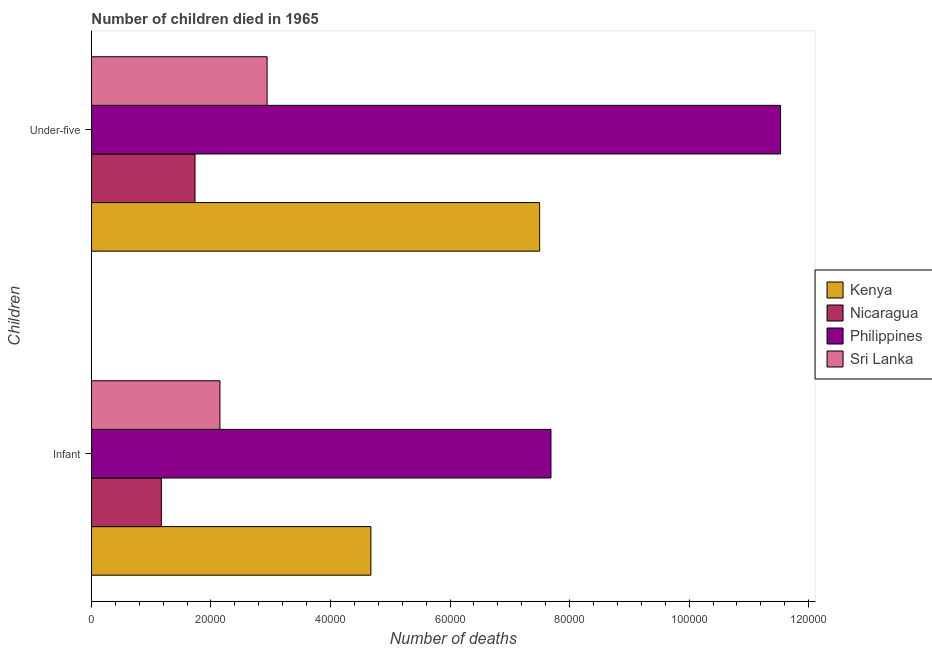How many different coloured bars are there?
Make the answer very short. 4. How many bars are there on the 2nd tick from the top?
Ensure brevity in your answer.  4. What is the label of the 2nd group of bars from the top?
Your response must be concise. Infant. What is the number of under-five deaths in Sri Lanka?
Provide a succinct answer. 2.94e+04. Across all countries, what is the maximum number of infant deaths?
Ensure brevity in your answer.  7.69e+04. Across all countries, what is the minimum number of under-five deaths?
Your response must be concise. 1.73e+04. In which country was the number of under-five deaths minimum?
Your answer should be compact. Nicaragua. What is the total number of under-five deaths in the graph?
Your answer should be compact. 2.37e+05. What is the difference between the number of infant deaths in Sri Lanka and that in Kenya?
Offer a terse response. -2.53e+04. What is the difference between the number of under-five deaths in Philippines and the number of infant deaths in Sri Lanka?
Your response must be concise. 9.38e+04. What is the average number of infant deaths per country?
Your answer should be compact. 3.92e+04. What is the difference between the number of infant deaths and number of under-five deaths in Sri Lanka?
Give a very brief answer. -7895. In how many countries, is the number of under-five deaths greater than 36000 ?
Your answer should be compact. 2. What is the ratio of the number of infant deaths in Nicaragua to that in Kenya?
Give a very brief answer. 0.25. Is the number of infant deaths in Kenya less than that in Nicaragua?
Give a very brief answer. No. In how many countries, is the number of infant deaths greater than the average number of infant deaths taken over all countries?
Make the answer very short. 2. What does the 4th bar from the top in Infant represents?
Offer a very short reply. Kenya. What does the 4th bar from the bottom in Under-five represents?
Ensure brevity in your answer.  Sri Lanka. How many bars are there?
Make the answer very short. 8. Are all the bars in the graph horizontal?
Offer a very short reply. Yes. How many countries are there in the graph?
Give a very brief answer. 4. Are the values on the major ticks of X-axis written in scientific E-notation?
Make the answer very short. No. Does the graph contain any zero values?
Provide a succinct answer. No. Where does the legend appear in the graph?
Make the answer very short. Center right. How many legend labels are there?
Offer a terse response. 4. What is the title of the graph?
Your response must be concise. Number of children died in 1965. Does "Solomon Islands" appear as one of the legend labels in the graph?
Your response must be concise. No. What is the label or title of the X-axis?
Your answer should be very brief. Number of deaths. What is the label or title of the Y-axis?
Your answer should be compact. Children. What is the Number of deaths of Kenya in Infant?
Provide a short and direct response. 4.68e+04. What is the Number of deaths in Nicaragua in Infant?
Offer a very short reply. 1.17e+04. What is the Number of deaths in Philippines in Infant?
Keep it short and to the point. 7.69e+04. What is the Number of deaths of Sri Lanka in Infant?
Your answer should be compact. 2.15e+04. What is the Number of deaths of Kenya in Under-five?
Give a very brief answer. 7.50e+04. What is the Number of deaths in Nicaragua in Under-five?
Your answer should be compact. 1.73e+04. What is the Number of deaths in Philippines in Under-five?
Your response must be concise. 1.15e+05. What is the Number of deaths of Sri Lanka in Under-five?
Ensure brevity in your answer.  2.94e+04. Across all Children, what is the maximum Number of deaths of Kenya?
Give a very brief answer. 7.50e+04. Across all Children, what is the maximum Number of deaths of Nicaragua?
Provide a succinct answer. 1.73e+04. Across all Children, what is the maximum Number of deaths in Philippines?
Your answer should be compact. 1.15e+05. Across all Children, what is the maximum Number of deaths in Sri Lanka?
Provide a succinct answer. 2.94e+04. Across all Children, what is the minimum Number of deaths of Kenya?
Your response must be concise. 4.68e+04. Across all Children, what is the minimum Number of deaths of Nicaragua?
Provide a short and direct response. 1.17e+04. Across all Children, what is the minimum Number of deaths in Philippines?
Ensure brevity in your answer.  7.69e+04. Across all Children, what is the minimum Number of deaths of Sri Lanka?
Offer a very short reply. 2.15e+04. What is the total Number of deaths in Kenya in the graph?
Provide a short and direct response. 1.22e+05. What is the total Number of deaths in Nicaragua in the graph?
Offer a terse response. 2.90e+04. What is the total Number of deaths in Philippines in the graph?
Provide a short and direct response. 1.92e+05. What is the total Number of deaths in Sri Lanka in the graph?
Give a very brief answer. 5.09e+04. What is the difference between the Number of deaths of Kenya in Infant and that in Under-five?
Make the answer very short. -2.82e+04. What is the difference between the Number of deaths of Nicaragua in Infant and that in Under-five?
Give a very brief answer. -5639. What is the difference between the Number of deaths in Philippines in Infant and that in Under-five?
Provide a succinct answer. -3.84e+04. What is the difference between the Number of deaths of Sri Lanka in Infant and that in Under-five?
Offer a terse response. -7895. What is the difference between the Number of deaths in Kenya in Infant and the Number of deaths in Nicaragua in Under-five?
Ensure brevity in your answer.  2.94e+04. What is the difference between the Number of deaths of Kenya in Infant and the Number of deaths of Philippines in Under-five?
Offer a terse response. -6.85e+04. What is the difference between the Number of deaths in Kenya in Infant and the Number of deaths in Sri Lanka in Under-five?
Make the answer very short. 1.74e+04. What is the difference between the Number of deaths in Nicaragua in Infant and the Number of deaths in Philippines in Under-five?
Your answer should be very brief. -1.04e+05. What is the difference between the Number of deaths in Nicaragua in Infant and the Number of deaths in Sri Lanka in Under-five?
Your answer should be very brief. -1.77e+04. What is the difference between the Number of deaths of Philippines in Infant and the Number of deaths of Sri Lanka in Under-five?
Offer a very short reply. 4.75e+04. What is the average Number of deaths in Kenya per Children?
Provide a succinct answer. 6.09e+04. What is the average Number of deaths of Nicaragua per Children?
Your answer should be compact. 1.45e+04. What is the average Number of deaths of Philippines per Children?
Keep it short and to the point. 9.61e+04. What is the average Number of deaths of Sri Lanka per Children?
Give a very brief answer. 2.54e+04. What is the difference between the Number of deaths of Kenya and Number of deaths of Nicaragua in Infant?
Offer a terse response. 3.51e+04. What is the difference between the Number of deaths of Kenya and Number of deaths of Philippines in Infant?
Give a very brief answer. -3.01e+04. What is the difference between the Number of deaths of Kenya and Number of deaths of Sri Lanka in Infant?
Provide a succinct answer. 2.53e+04. What is the difference between the Number of deaths in Nicaragua and Number of deaths in Philippines in Infant?
Offer a very short reply. -6.52e+04. What is the difference between the Number of deaths of Nicaragua and Number of deaths of Sri Lanka in Infant?
Your response must be concise. -9806. What is the difference between the Number of deaths in Philippines and Number of deaths in Sri Lanka in Infant?
Offer a very short reply. 5.54e+04. What is the difference between the Number of deaths in Kenya and Number of deaths in Nicaragua in Under-five?
Offer a very short reply. 5.77e+04. What is the difference between the Number of deaths of Kenya and Number of deaths of Philippines in Under-five?
Your answer should be very brief. -4.03e+04. What is the difference between the Number of deaths of Kenya and Number of deaths of Sri Lanka in Under-five?
Keep it short and to the point. 4.56e+04. What is the difference between the Number of deaths in Nicaragua and Number of deaths in Philippines in Under-five?
Your response must be concise. -9.80e+04. What is the difference between the Number of deaths of Nicaragua and Number of deaths of Sri Lanka in Under-five?
Your answer should be compact. -1.21e+04. What is the difference between the Number of deaths of Philippines and Number of deaths of Sri Lanka in Under-five?
Offer a terse response. 8.59e+04. What is the ratio of the Number of deaths of Kenya in Infant to that in Under-five?
Provide a succinct answer. 0.62. What is the ratio of the Number of deaths in Nicaragua in Infant to that in Under-five?
Ensure brevity in your answer.  0.67. What is the ratio of the Number of deaths of Philippines in Infant to that in Under-five?
Make the answer very short. 0.67. What is the ratio of the Number of deaths of Sri Lanka in Infant to that in Under-five?
Ensure brevity in your answer.  0.73. What is the difference between the highest and the second highest Number of deaths of Kenya?
Your response must be concise. 2.82e+04. What is the difference between the highest and the second highest Number of deaths in Nicaragua?
Provide a short and direct response. 5639. What is the difference between the highest and the second highest Number of deaths in Philippines?
Give a very brief answer. 3.84e+04. What is the difference between the highest and the second highest Number of deaths in Sri Lanka?
Offer a very short reply. 7895. What is the difference between the highest and the lowest Number of deaths of Kenya?
Give a very brief answer. 2.82e+04. What is the difference between the highest and the lowest Number of deaths in Nicaragua?
Give a very brief answer. 5639. What is the difference between the highest and the lowest Number of deaths in Philippines?
Your answer should be very brief. 3.84e+04. What is the difference between the highest and the lowest Number of deaths of Sri Lanka?
Provide a short and direct response. 7895. 